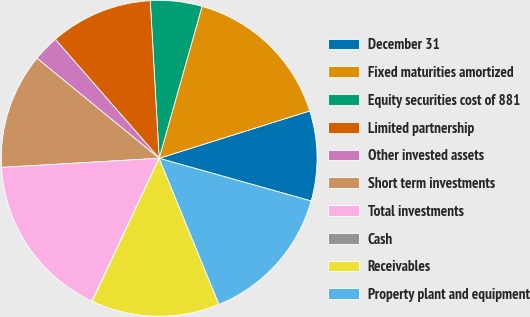Convert chart to OTSL. <chart><loc_0><loc_0><loc_500><loc_500><pie_chart><fcel>December 31<fcel>Fixed maturities amortized<fcel>Equity securities cost of 881<fcel>Limited partnership<fcel>Other invested assets<fcel>Short term investments<fcel>Total investments<fcel>Cash<fcel>Receivables<fcel>Property plant and equipment<nl><fcel>9.21%<fcel>15.77%<fcel>5.28%<fcel>10.52%<fcel>2.66%<fcel>11.84%<fcel>17.08%<fcel>0.04%<fcel>13.15%<fcel>14.46%<nl></chart> 